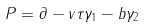Convert formula to latex. <formula><loc_0><loc_0><loc_500><loc_500>P = \partial - v \tau \gamma _ { 1 } - b \gamma _ { 2 }</formula> 